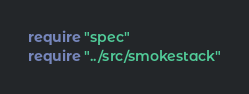Convert code to text. <code><loc_0><loc_0><loc_500><loc_500><_Crystal_>require "spec"
require "../src/smokestack"
</code> 